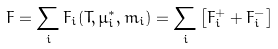Convert formula to latex. <formula><loc_0><loc_0><loc_500><loc_500>F = \sum _ { i } F _ { i } ( T , \mu _ { i } ^ { * } , m _ { i } ) = \sum _ { i } \left [ F _ { i } ^ { + } + F _ { i } ^ { - } \right ]</formula> 